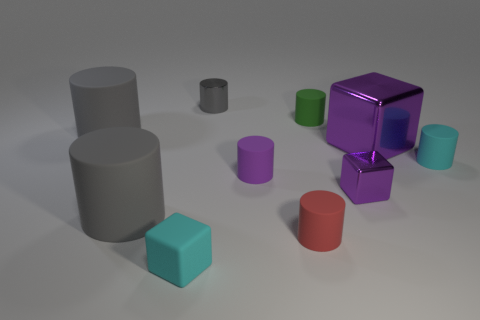Subtract all cyan rubber cylinders. How many cylinders are left? 6 Subtract all cylinders. How many objects are left? 3 Subtract 6 cylinders. How many cylinders are left? 1 Subtract all gray metallic objects. Subtract all blue rubber blocks. How many objects are left? 9 Add 4 tiny green cylinders. How many tiny green cylinders are left? 5 Add 6 small gray cylinders. How many small gray cylinders exist? 7 Subtract all purple cubes. How many cubes are left? 1 Subtract 1 red cylinders. How many objects are left? 9 Subtract all brown cylinders. Subtract all brown spheres. How many cylinders are left? 7 Subtract all blue blocks. How many cyan cylinders are left? 1 